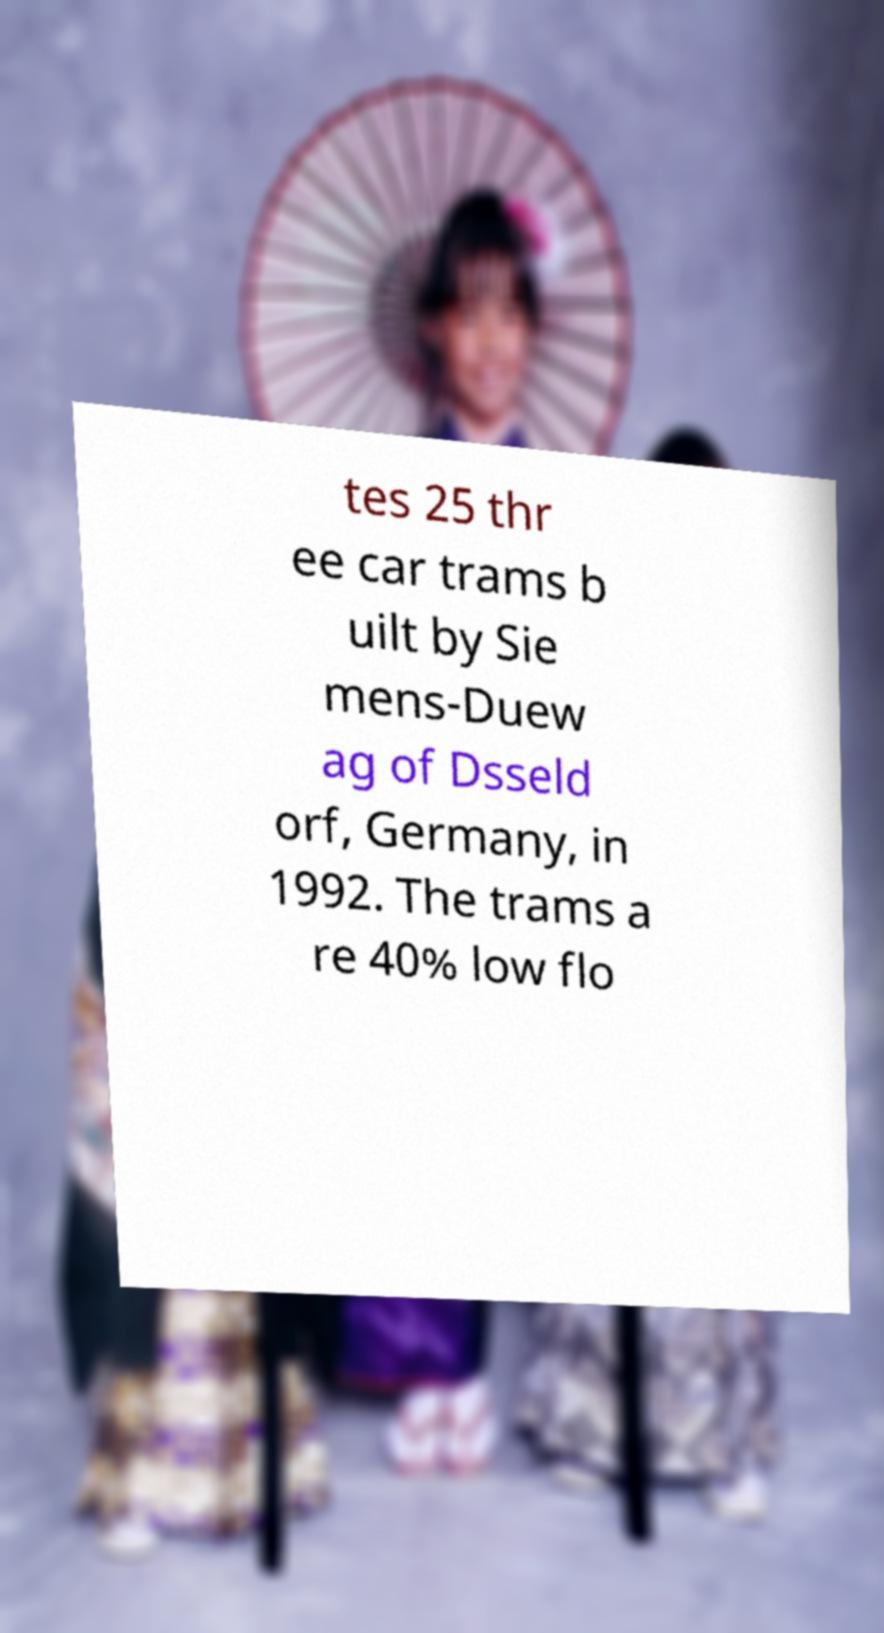Please identify and transcribe the text found in this image. tes 25 thr ee car trams b uilt by Sie mens-Duew ag of Dsseld orf, Germany, in 1992. The trams a re 40% low flo 